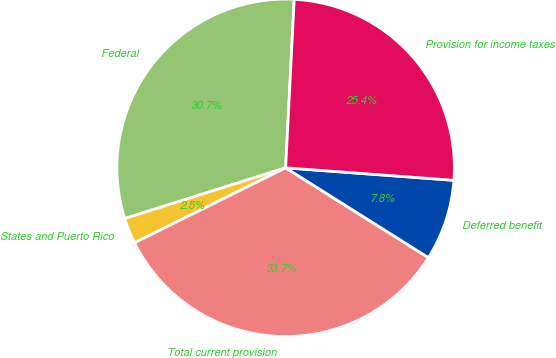Convert chart. <chart><loc_0><loc_0><loc_500><loc_500><pie_chart><fcel>Federal<fcel>States and Puerto Rico<fcel>Total current provision<fcel>Deferred benefit<fcel>Provision for income taxes<nl><fcel>30.67%<fcel>2.47%<fcel>33.73%<fcel>7.76%<fcel>25.37%<nl></chart> 